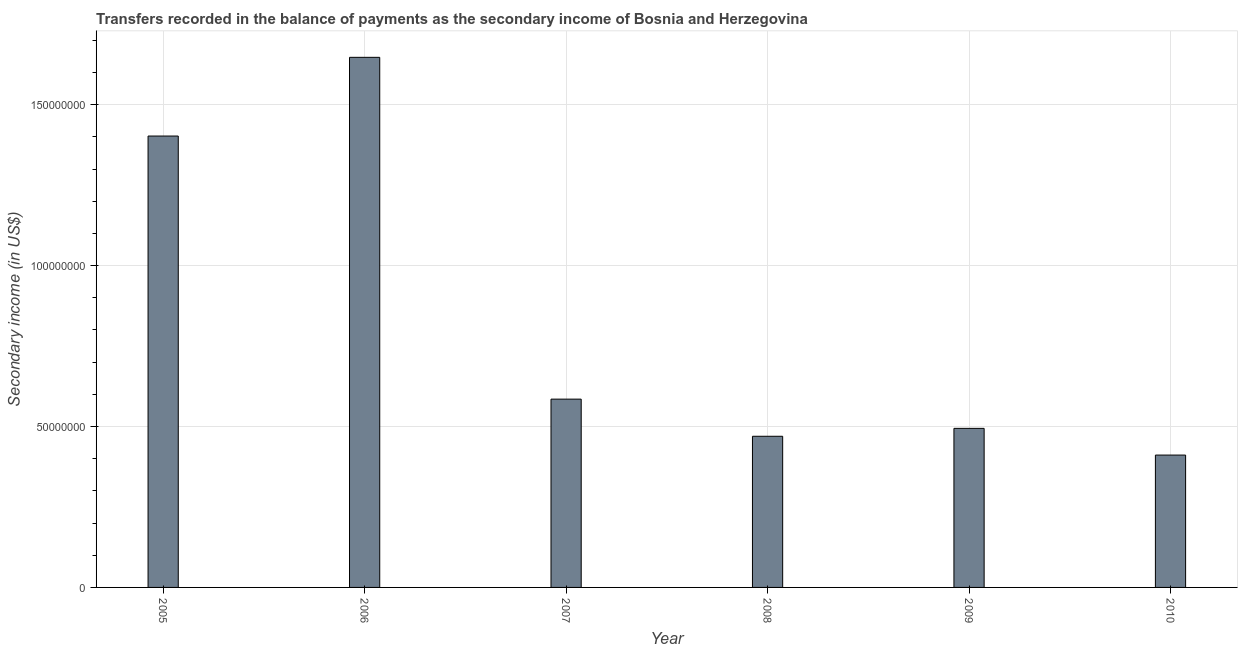What is the title of the graph?
Your answer should be very brief. Transfers recorded in the balance of payments as the secondary income of Bosnia and Herzegovina. What is the label or title of the Y-axis?
Ensure brevity in your answer.  Secondary income (in US$). What is the amount of secondary income in 2010?
Provide a short and direct response. 4.11e+07. Across all years, what is the maximum amount of secondary income?
Offer a very short reply. 1.65e+08. Across all years, what is the minimum amount of secondary income?
Give a very brief answer. 4.11e+07. In which year was the amount of secondary income maximum?
Your answer should be very brief. 2006. In which year was the amount of secondary income minimum?
Provide a succinct answer. 2010. What is the sum of the amount of secondary income?
Keep it short and to the point. 5.01e+08. What is the difference between the amount of secondary income in 2008 and 2009?
Offer a very short reply. -2.46e+06. What is the average amount of secondary income per year?
Your answer should be compact. 8.35e+07. What is the median amount of secondary income?
Provide a short and direct response. 5.40e+07. Do a majority of the years between 2009 and 2005 (inclusive) have amount of secondary income greater than 160000000 US$?
Offer a terse response. Yes. What is the ratio of the amount of secondary income in 2009 to that in 2010?
Your response must be concise. 1.2. Is the amount of secondary income in 2006 less than that in 2008?
Offer a terse response. No. What is the difference between the highest and the second highest amount of secondary income?
Offer a very short reply. 2.45e+07. Is the sum of the amount of secondary income in 2007 and 2008 greater than the maximum amount of secondary income across all years?
Keep it short and to the point. No. What is the difference between the highest and the lowest amount of secondary income?
Provide a short and direct response. 1.24e+08. How many bars are there?
Make the answer very short. 6. Are all the bars in the graph horizontal?
Provide a succinct answer. No. How many years are there in the graph?
Offer a terse response. 6. What is the difference between two consecutive major ticks on the Y-axis?
Keep it short and to the point. 5.00e+07. What is the Secondary income (in US$) in 2005?
Offer a terse response. 1.40e+08. What is the Secondary income (in US$) in 2006?
Ensure brevity in your answer.  1.65e+08. What is the Secondary income (in US$) in 2007?
Offer a terse response. 5.85e+07. What is the Secondary income (in US$) in 2008?
Your answer should be very brief. 4.70e+07. What is the Secondary income (in US$) of 2009?
Offer a very short reply. 4.94e+07. What is the Secondary income (in US$) in 2010?
Ensure brevity in your answer.  4.11e+07. What is the difference between the Secondary income (in US$) in 2005 and 2006?
Offer a terse response. -2.45e+07. What is the difference between the Secondary income (in US$) in 2005 and 2007?
Offer a terse response. 8.17e+07. What is the difference between the Secondary income (in US$) in 2005 and 2008?
Give a very brief answer. 9.33e+07. What is the difference between the Secondary income (in US$) in 2005 and 2009?
Your response must be concise. 9.08e+07. What is the difference between the Secondary income (in US$) in 2005 and 2010?
Keep it short and to the point. 9.91e+07. What is the difference between the Secondary income (in US$) in 2006 and 2007?
Offer a very short reply. 1.06e+08. What is the difference between the Secondary income (in US$) in 2006 and 2008?
Offer a very short reply. 1.18e+08. What is the difference between the Secondary income (in US$) in 2006 and 2009?
Make the answer very short. 1.15e+08. What is the difference between the Secondary income (in US$) in 2006 and 2010?
Provide a succinct answer. 1.24e+08. What is the difference between the Secondary income (in US$) in 2007 and 2008?
Your answer should be compact. 1.15e+07. What is the difference between the Secondary income (in US$) in 2007 and 2009?
Give a very brief answer. 9.08e+06. What is the difference between the Secondary income (in US$) in 2007 and 2010?
Give a very brief answer. 1.74e+07. What is the difference between the Secondary income (in US$) in 2008 and 2009?
Provide a short and direct response. -2.46e+06. What is the difference between the Secondary income (in US$) in 2008 and 2010?
Your answer should be very brief. 5.84e+06. What is the difference between the Secondary income (in US$) in 2009 and 2010?
Offer a very short reply. 8.30e+06. What is the ratio of the Secondary income (in US$) in 2005 to that in 2006?
Offer a terse response. 0.85. What is the ratio of the Secondary income (in US$) in 2005 to that in 2007?
Keep it short and to the point. 2.4. What is the ratio of the Secondary income (in US$) in 2005 to that in 2008?
Keep it short and to the point. 2.99. What is the ratio of the Secondary income (in US$) in 2005 to that in 2009?
Ensure brevity in your answer.  2.84. What is the ratio of the Secondary income (in US$) in 2005 to that in 2010?
Your answer should be compact. 3.41. What is the ratio of the Secondary income (in US$) in 2006 to that in 2007?
Provide a succinct answer. 2.81. What is the ratio of the Secondary income (in US$) in 2006 to that in 2008?
Your answer should be compact. 3.51. What is the ratio of the Secondary income (in US$) in 2006 to that in 2009?
Make the answer very short. 3.33. What is the ratio of the Secondary income (in US$) in 2006 to that in 2010?
Offer a terse response. 4. What is the ratio of the Secondary income (in US$) in 2007 to that in 2008?
Offer a terse response. 1.25. What is the ratio of the Secondary income (in US$) in 2007 to that in 2009?
Your answer should be very brief. 1.18. What is the ratio of the Secondary income (in US$) in 2007 to that in 2010?
Give a very brief answer. 1.42. What is the ratio of the Secondary income (in US$) in 2008 to that in 2009?
Offer a terse response. 0.95. What is the ratio of the Secondary income (in US$) in 2008 to that in 2010?
Make the answer very short. 1.14. What is the ratio of the Secondary income (in US$) in 2009 to that in 2010?
Provide a succinct answer. 1.2. 